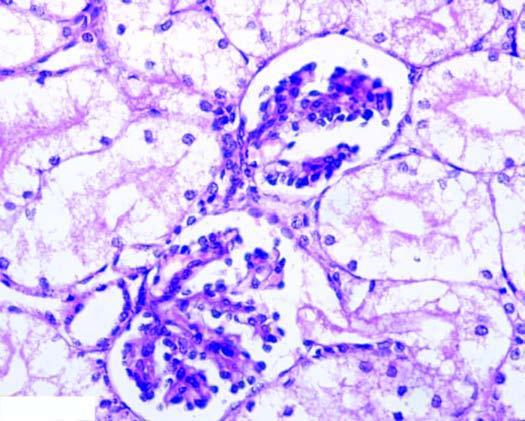what are the tubular epithelial cells distended with?
Answer the question using a single word or phrase. Cytoplasmic vacuoles 